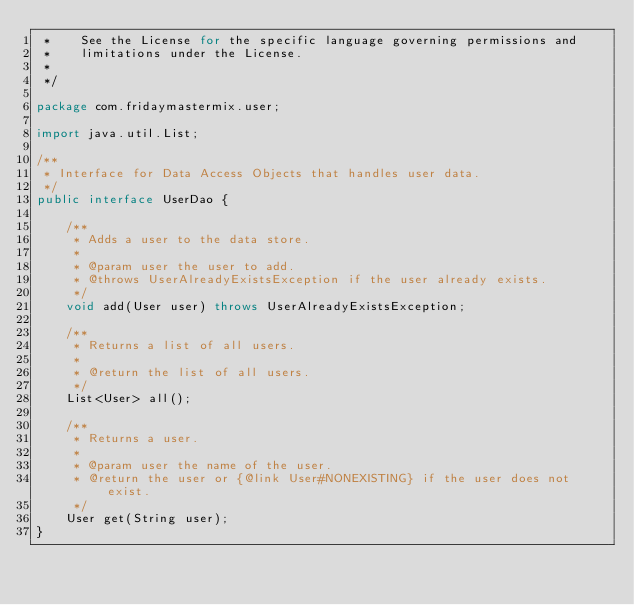Convert code to text. <code><loc_0><loc_0><loc_500><loc_500><_Java_> *    See the License for the specific language governing permissions and
 *    limitations under the License.
 *
 */

package com.fridaymastermix.user;

import java.util.List;

/**
 * Interface for Data Access Objects that handles user data.
 */
public interface UserDao {

    /**
     * Adds a user to the data store.
     *
     * @param user the user to add.
     * @throws UserAlreadyExistsException if the user already exists.
     */
    void add(User user) throws UserAlreadyExistsException;

    /**
     * Returns a list of all users.
     *
     * @return the list of all users.
     */
    List<User> all();

    /**
     * Returns a user.
     *
     * @param user the name of the user.
     * @return the user or {@link User#NONEXISTING} if the user does not exist.
     */
    User get(String user);
}
</code> 